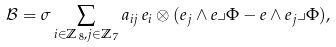Convert formula to latex. <formula><loc_0><loc_0><loc_500><loc_500>\mathcal { B } = \sigma \sum _ { i \in { \mathbb { Z } } _ { \, 8 } , j \in { \mathbb { Z } } _ { \, 7 } } a _ { i j } \, e _ { i } \otimes ( e _ { j } \wedge e \lrcorner \Phi - e \wedge e _ { j } \lrcorner \Phi ) ,</formula> 